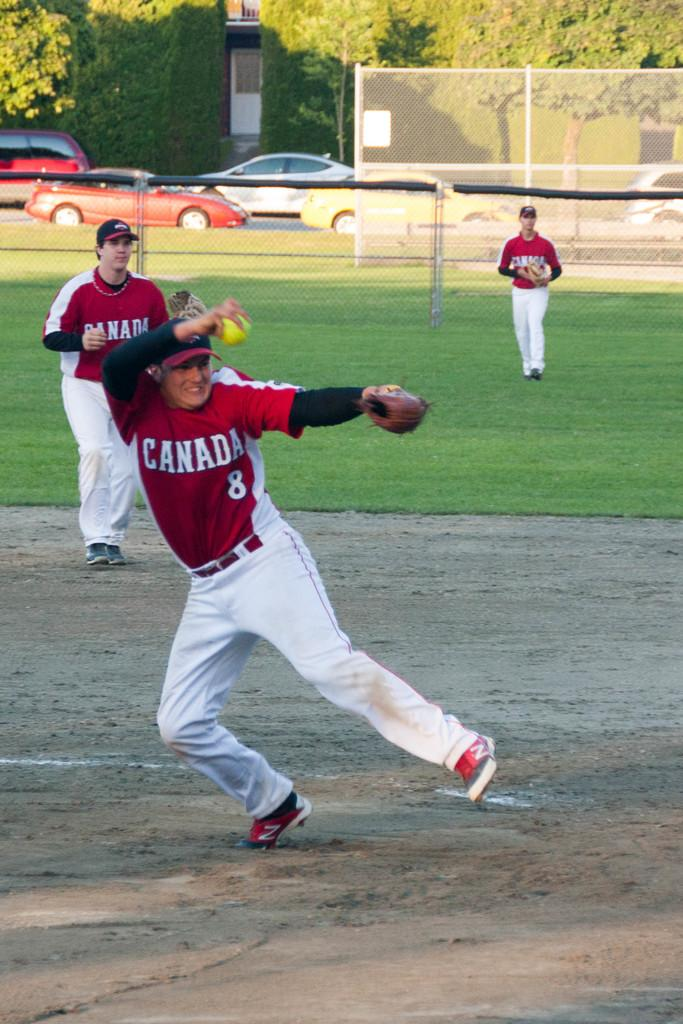<image>
Describe the image concisely. A man wearing a Canada shirt throws a ball. 